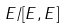Convert formula to latex. <formula><loc_0><loc_0><loc_500><loc_500>E / [ E , E ]</formula> 